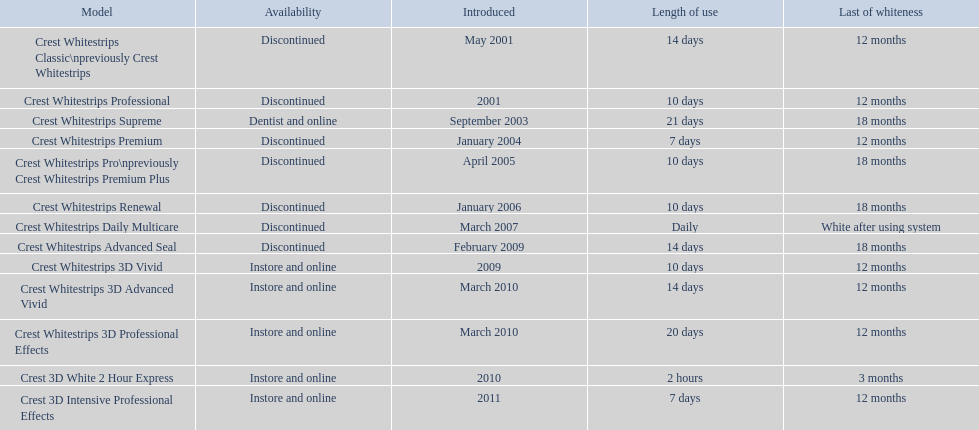How many models necessitate usage for less than a week? 2. 